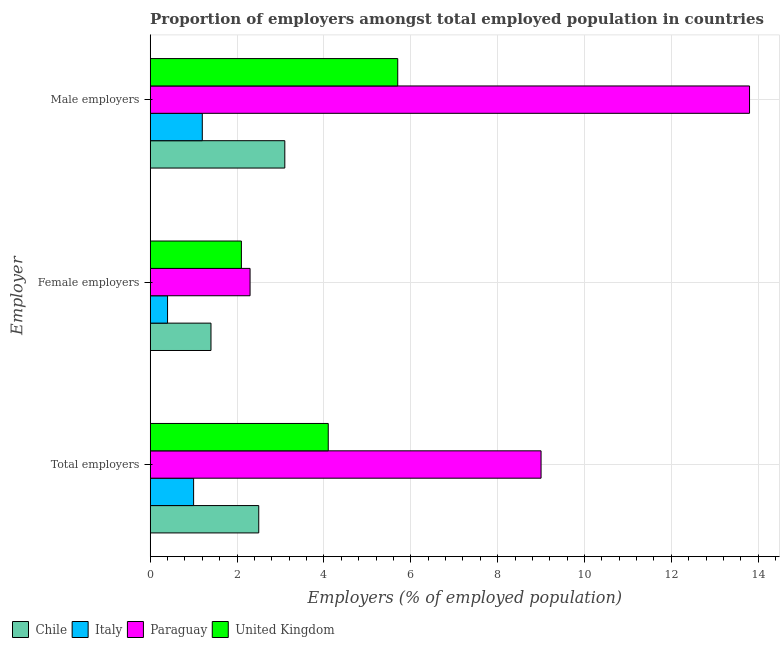How many groups of bars are there?
Keep it short and to the point. 3. Are the number of bars per tick equal to the number of legend labels?
Make the answer very short. Yes. How many bars are there on the 3rd tick from the bottom?
Offer a terse response. 4. What is the label of the 2nd group of bars from the top?
Provide a short and direct response. Female employers. What is the percentage of male employers in Paraguay?
Give a very brief answer. 13.8. Across all countries, what is the maximum percentage of female employers?
Your answer should be very brief. 2.3. Across all countries, what is the minimum percentage of female employers?
Provide a succinct answer. 0.4. In which country was the percentage of male employers maximum?
Offer a very short reply. Paraguay. What is the total percentage of total employers in the graph?
Your answer should be very brief. 16.6. What is the difference between the percentage of female employers in Chile and that in Italy?
Offer a very short reply. 1. What is the difference between the percentage of total employers in Chile and the percentage of female employers in Paraguay?
Offer a terse response. 0.2. What is the average percentage of male employers per country?
Keep it short and to the point. 5.95. What is the difference between the percentage of female employers and percentage of total employers in Chile?
Provide a short and direct response. -1.1. What is the ratio of the percentage of male employers in Chile to that in United Kingdom?
Keep it short and to the point. 0.54. What is the difference between the highest and the second highest percentage of total employers?
Give a very brief answer. 4.9. What is the difference between the highest and the lowest percentage of total employers?
Your response must be concise. 8. Is the sum of the percentage of male employers in Chile and Paraguay greater than the maximum percentage of total employers across all countries?
Your answer should be very brief. Yes. What does the 2nd bar from the bottom in Female employers represents?
Give a very brief answer. Italy. Does the graph contain any zero values?
Give a very brief answer. No. Does the graph contain grids?
Offer a terse response. Yes. Where does the legend appear in the graph?
Your answer should be compact. Bottom left. How many legend labels are there?
Keep it short and to the point. 4. How are the legend labels stacked?
Offer a very short reply. Horizontal. What is the title of the graph?
Your response must be concise. Proportion of employers amongst total employed population in countries. What is the label or title of the X-axis?
Ensure brevity in your answer.  Employers (% of employed population). What is the label or title of the Y-axis?
Keep it short and to the point. Employer. What is the Employers (% of employed population) of Italy in Total employers?
Make the answer very short. 1. What is the Employers (% of employed population) in United Kingdom in Total employers?
Offer a very short reply. 4.1. What is the Employers (% of employed population) in Chile in Female employers?
Offer a very short reply. 1.4. What is the Employers (% of employed population) in Italy in Female employers?
Your answer should be very brief. 0.4. What is the Employers (% of employed population) in Paraguay in Female employers?
Your answer should be compact. 2.3. What is the Employers (% of employed population) in United Kingdom in Female employers?
Give a very brief answer. 2.1. What is the Employers (% of employed population) in Chile in Male employers?
Provide a succinct answer. 3.1. What is the Employers (% of employed population) of Italy in Male employers?
Offer a terse response. 1.2. What is the Employers (% of employed population) in Paraguay in Male employers?
Your answer should be very brief. 13.8. What is the Employers (% of employed population) in United Kingdom in Male employers?
Offer a terse response. 5.7. Across all Employer, what is the maximum Employers (% of employed population) in Chile?
Offer a terse response. 3.1. Across all Employer, what is the maximum Employers (% of employed population) in Italy?
Provide a succinct answer. 1.2. Across all Employer, what is the maximum Employers (% of employed population) of Paraguay?
Your answer should be very brief. 13.8. Across all Employer, what is the maximum Employers (% of employed population) of United Kingdom?
Ensure brevity in your answer.  5.7. Across all Employer, what is the minimum Employers (% of employed population) in Chile?
Provide a short and direct response. 1.4. Across all Employer, what is the minimum Employers (% of employed population) of Italy?
Your answer should be compact. 0.4. Across all Employer, what is the minimum Employers (% of employed population) in Paraguay?
Offer a terse response. 2.3. Across all Employer, what is the minimum Employers (% of employed population) of United Kingdom?
Offer a very short reply. 2.1. What is the total Employers (% of employed population) in Chile in the graph?
Your answer should be very brief. 7. What is the total Employers (% of employed population) of Paraguay in the graph?
Offer a very short reply. 25.1. What is the difference between the Employers (% of employed population) in Paraguay in Total employers and that in Female employers?
Provide a succinct answer. 6.7. What is the difference between the Employers (% of employed population) in United Kingdom in Total employers and that in Female employers?
Make the answer very short. 2. What is the difference between the Employers (% of employed population) in Chile in Total employers and that in Male employers?
Offer a terse response. -0.6. What is the difference between the Employers (% of employed population) in Paraguay in Total employers and that in Male employers?
Provide a succinct answer. -4.8. What is the difference between the Employers (% of employed population) of Chile in Female employers and that in Male employers?
Provide a succinct answer. -1.7. What is the difference between the Employers (% of employed population) of Italy in Female employers and that in Male employers?
Make the answer very short. -0.8. What is the difference between the Employers (% of employed population) in United Kingdom in Female employers and that in Male employers?
Provide a succinct answer. -3.6. What is the difference between the Employers (% of employed population) of Chile in Total employers and the Employers (% of employed population) of Italy in Female employers?
Your answer should be very brief. 2.1. What is the difference between the Employers (% of employed population) of Chile in Total employers and the Employers (% of employed population) of Paraguay in Female employers?
Provide a short and direct response. 0.2. What is the difference between the Employers (% of employed population) of Italy in Total employers and the Employers (% of employed population) of Paraguay in Female employers?
Keep it short and to the point. -1.3. What is the difference between the Employers (% of employed population) in Italy in Total employers and the Employers (% of employed population) in United Kingdom in Female employers?
Give a very brief answer. -1.1. What is the difference between the Employers (% of employed population) of Chile in Total employers and the Employers (% of employed population) of Italy in Male employers?
Your response must be concise. 1.3. What is the difference between the Employers (% of employed population) in Chile in Total employers and the Employers (% of employed population) in United Kingdom in Male employers?
Keep it short and to the point. -3.2. What is the difference between the Employers (% of employed population) of Paraguay in Total employers and the Employers (% of employed population) of United Kingdom in Male employers?
Provide a short and direct response. 3.3. What is the difference between the Employers (% of employed population) of Chile in Female employers and the Employers (% of employed population) of Italy in Male employers?
Offer a terse response. 0.2. What is the difference between the Employers (% of employed population) in Chile in Female employers and the Employers (% of employed population) in United Kingdom in Male employers?
Provide a succinct answer. -4.3. What is the difference between the Employers (% of employed population) in Italy in Female employers and the Employers (% of employed population) in Paraguay in Male employers?
Your answer should be compact. -13.4. What is the difference between the Employers (% of employed population) of Italy in Female employers and the Employers (% of employed population) of United Kingdom in Male employers?
Provide a short and direct response. -5.3. What is the difference between the Employers (% of employed population) of Paraguay in Female employers and the Employers (% of employed population) of United Kingdom in Male employers?
Your response must be concise. -3.4. What is the average Employers (% of employed population) of Chile per Employer?
Keep it short and to the point. 2.33. What is the average Employers (% of employed population) in Italy per Employer?
Keep it short and to the point. 0.87. What is the average Employers (% of employed population) in Paraguay per Employer?
Keep it short and to the point. 8.37. What is the average Employers (% of employed population) in United Kingdom per Employer?
Offer a terse response. 3.97. What is the difference between the Employers (% of employed population) of Italy and Employers (% of employed population) of Paraguay in Total employers?
Your response must be concise. -8. What is the difference between the Employers (% of employed population) of Italy and Employers (% of employed population) of United Kingdom in Total employers?
Keep it short and to the point. -3.1. What is the difference between the Employers (% of employed population) of Paraguay and Employers (% of employed population) of United Kingdom in Total employers?
Provide a short and direct response. 4.9. What is the difference between the Employers (% of employed population) of Chile and Employers (% of employed population) of Italy in Female employers?
Offer a terse response. 1. What is the difference between the Employers (% of employed population) in Chile and Employers (% of employed population) in United Kingdom in Female employers?
Your answer should be compact. -0.7. What is the ratio of the Employers (% of employed population) of Chile in Total employers to that in Female employers?
Provide a short and direct response. 1.79. What is the ratio of the Employers (% of employed population) of Paraguay in Total employers to that in Female employers?
Give a very brief answer. 3.91. What is the ratio of the Employers (% of employed population) of United Kingdom in Total employers to that in Female employers?
Provide a short and direct response. 1.95. What is the ratio of the Employers (% of employed population) of Chile in Total employers to that in Male employers?
Make the answer very short. 0.81. What is the ratio of the Employers (% of employed population) of Italy in Total employers to that in Male employers?
Offer a very short reply. 0.83. What is the ratio of the Employers (% of employed population) in Paraguay in Total employers to that in Male employers?
Offer a very short reply. 0.65. What is the ratio of the Employers (% of employed population) of United Kingdom in Total employers to that in Male employers?
Make the answer very short. 0.72. What is the ratio of the Employers (% of employed population) in Chile in Female employers to that in Male employers?
Provide a succinct answer. 0.45. What is the ratio of the Employers (% of employed population) of Paraguay in Female employers to that in Male employers?
Ensure brevity in your answer.  0.17. What is the ratio of the Employers (% of employed population) in United Kingdom in Female employers to that in Male employers?
Give a very brief answer. 0.37. What is the difference between the highest and the second highest Employers (% of employed population) of Paraguay?
Give a very brief answer. 4.8. What is the difference between the highest and the second highest Employers (% of employed population) in United Kingdom?
Keep it short and to the point. 1.6. What is the difference between the highest and the lowest Employers (% of employed population) of Chile?
Your response must be concise. 1.7. What is the difference between the highest and the lowest Employers (% of employed population) of Italy?
Offer a terse response. 0.8. What is the difference between the highest and the lowest Employers (% of employed population) of Paraguay?
Provide a short and direct response. 11.5. 